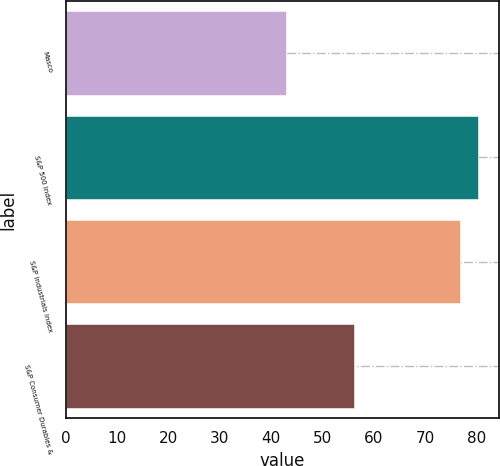Convert chart to OTSL. <chart><loc_0><loc_0><loc_500><loc_500><bar_chart><fcel>Masco<fcel>S&P 500 Index<fcel>S&P Industrials Index<fcel>S&P Consumer Durables &<nl><fcel>42.81<fcel>80.25<fcel>76.79<fcel>56.13<nl></chart> 